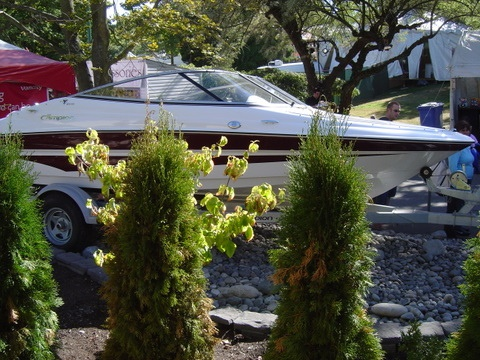Describe the objects in this image and their specific colors. I can see boat in black, darkgray, and gray tones, people in black, blue, gray, and navy tones, people in black and gray tones, people in black, maroon, and brown tones, and people in black, gray, and darkgray tones in this image. 